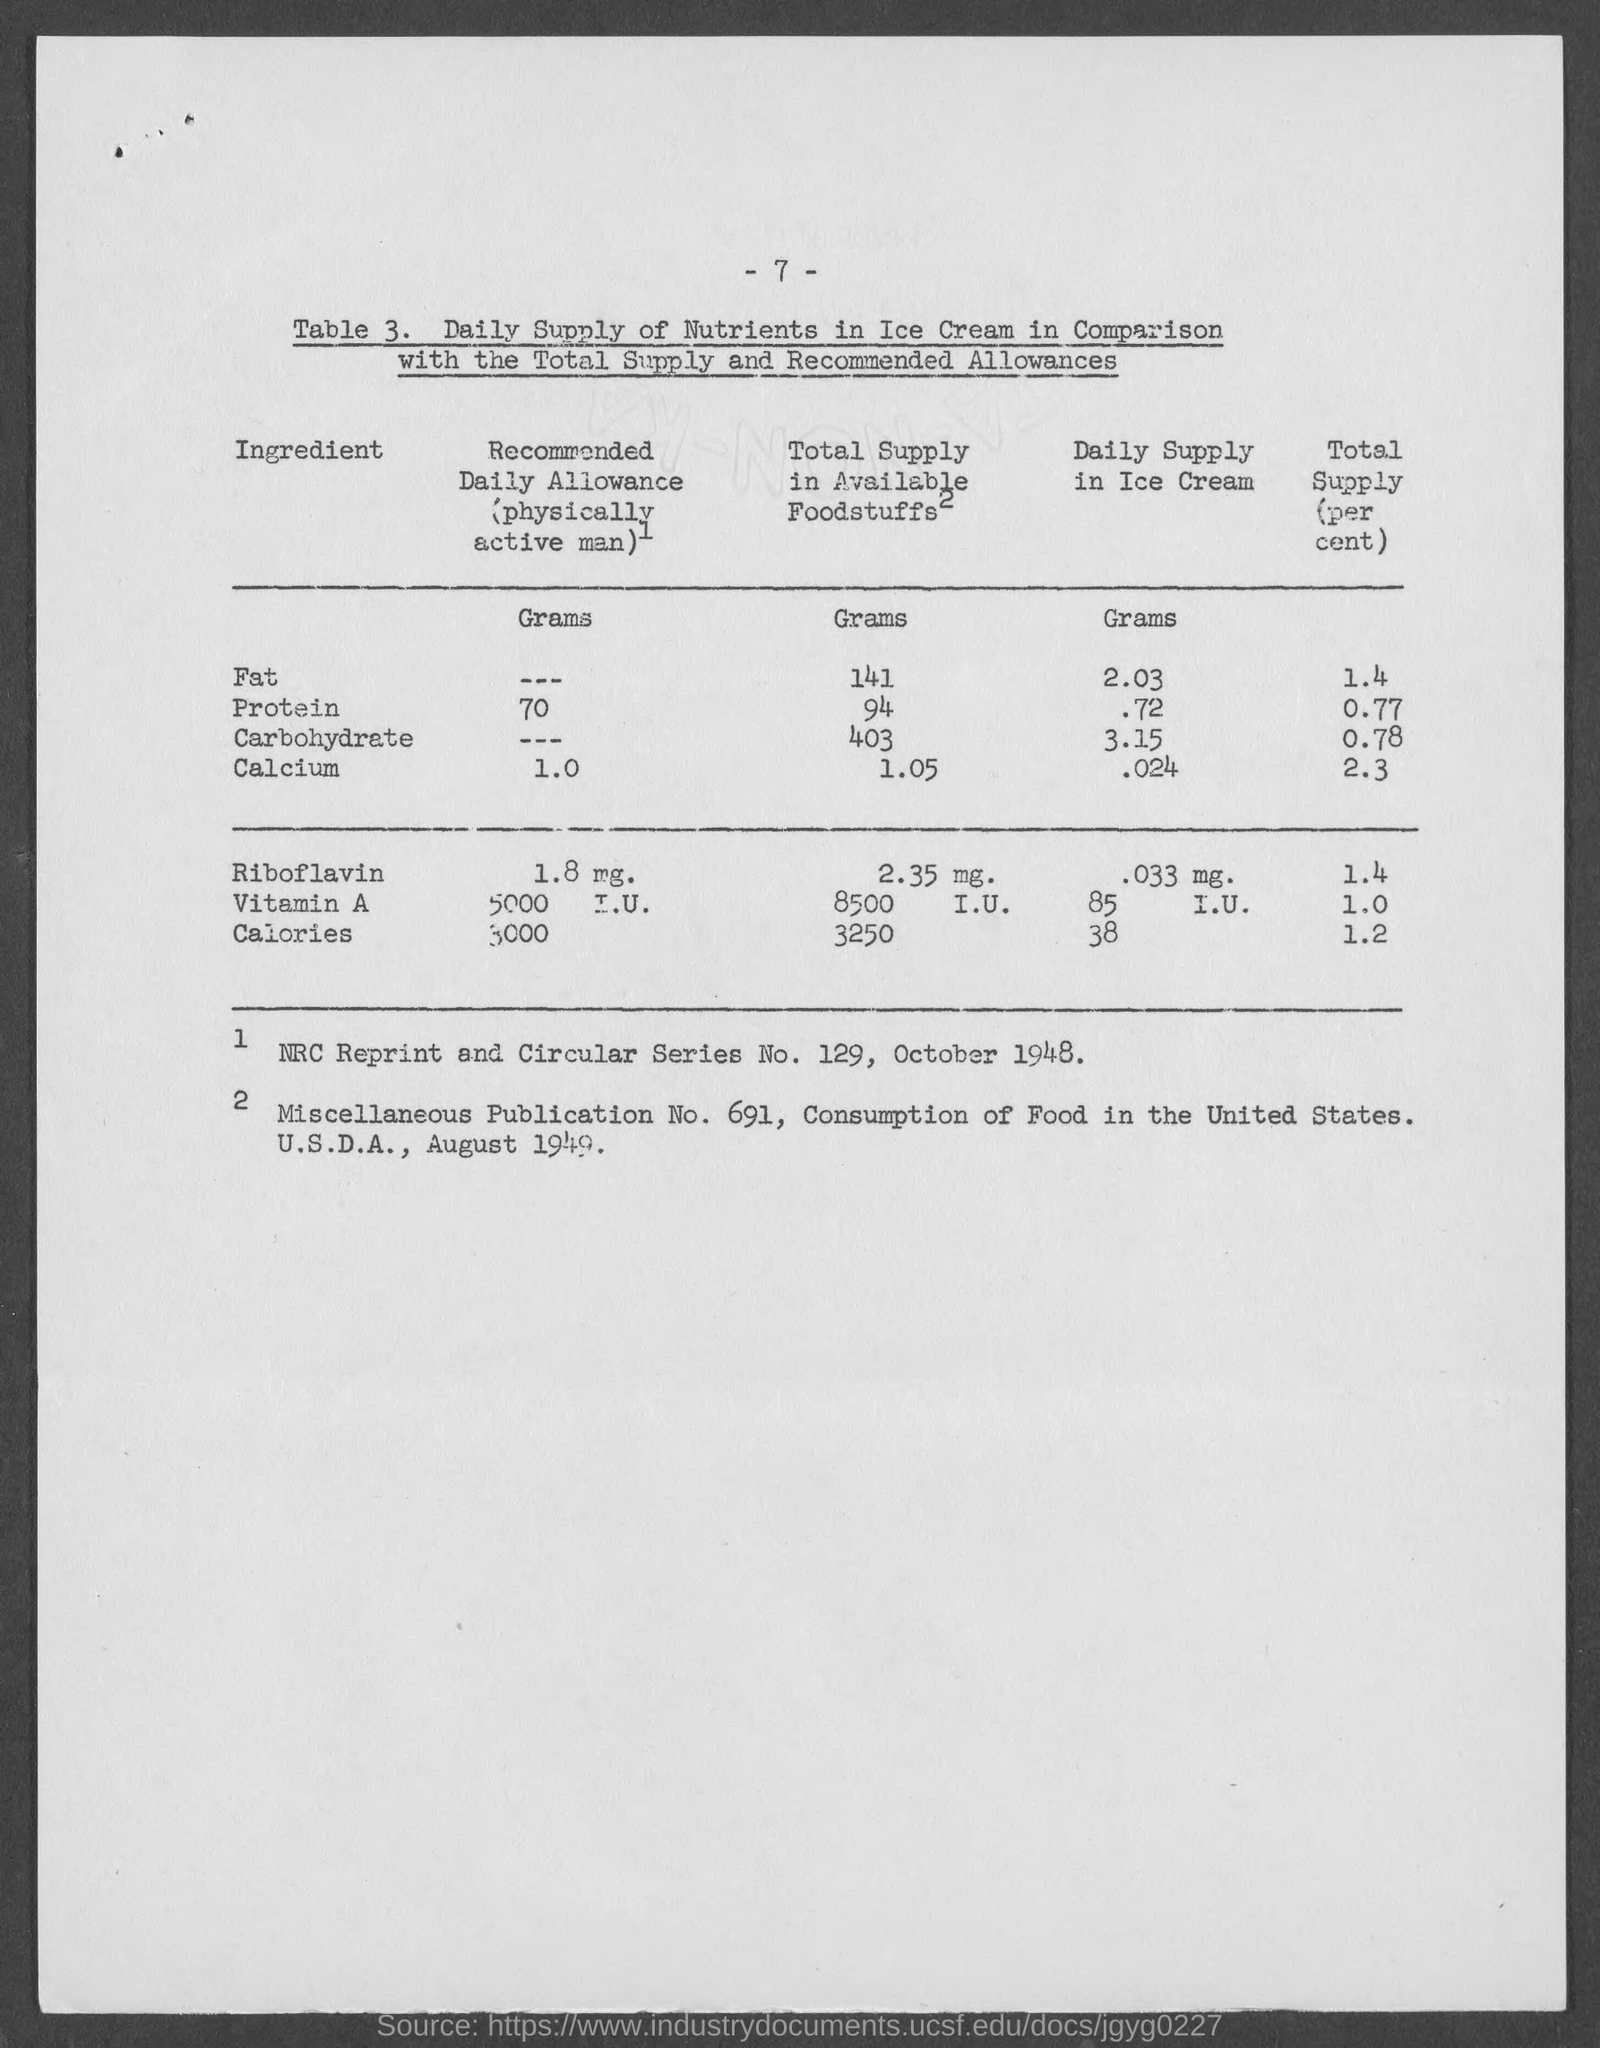What is the number at top of the page ?
Offer a terse response. - 7 -. 